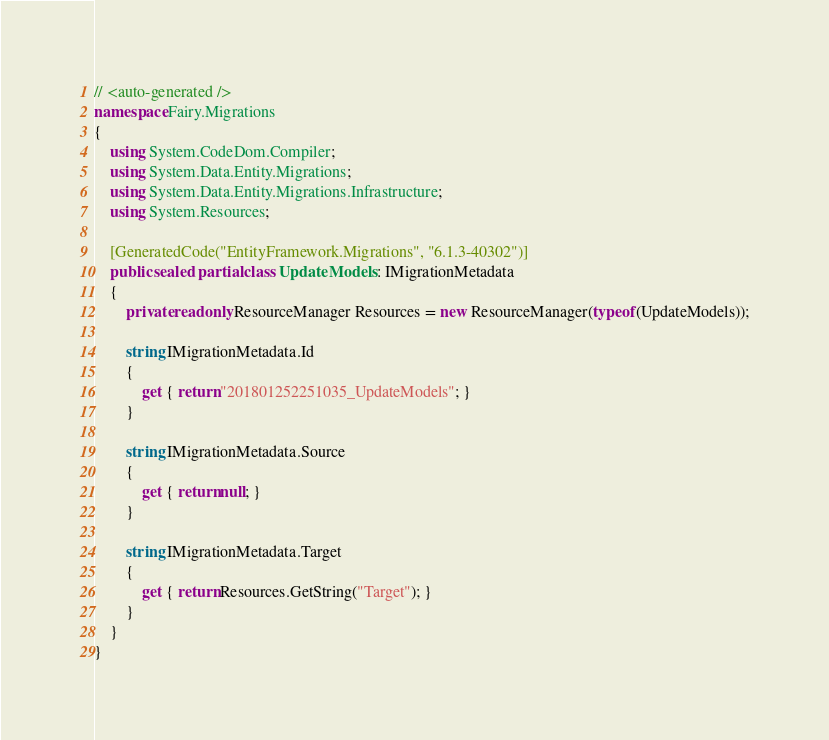Convert code to text. <code><loc_0><loc_0><loc_500><loc_500><_C#_>// <auto-generated />
namespace Fairy.Migrations
{
    using System.CodeDom.Compiler;
    using System.Data.Entity.Migrations;
    using System.Data.Entity.Migrations.Infrastructure;
    using System.Resources;
    
    [GeneratedCode("EntityFramework.Migrations", "6.1.3-40302")]
    public sealed partial class UpdateModels : IMigrationMetadata
    {
        private readonly ResourceManager Resources = new ResourceManager(typeof(UpdateModels));
        
        string IMigrationMetadata.Id
        {
            get { return "201801252251035_UpdateModels"; }
        }
        
        string IMigrationMetadata.Source
        {
            get { return null; }
        }
        
        string IMigrationMetadata.Target
        {
            get { return Resources.GetString("Target"); }
        }
    }
}
</code> 